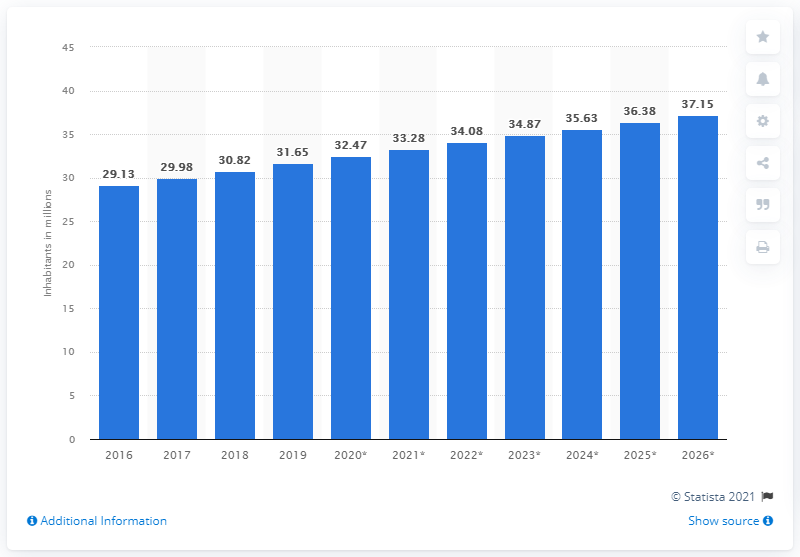Draw attention to some important aspects in this diagram. As of 2019, the population of Yemen was estimated to be 31.65 million. 